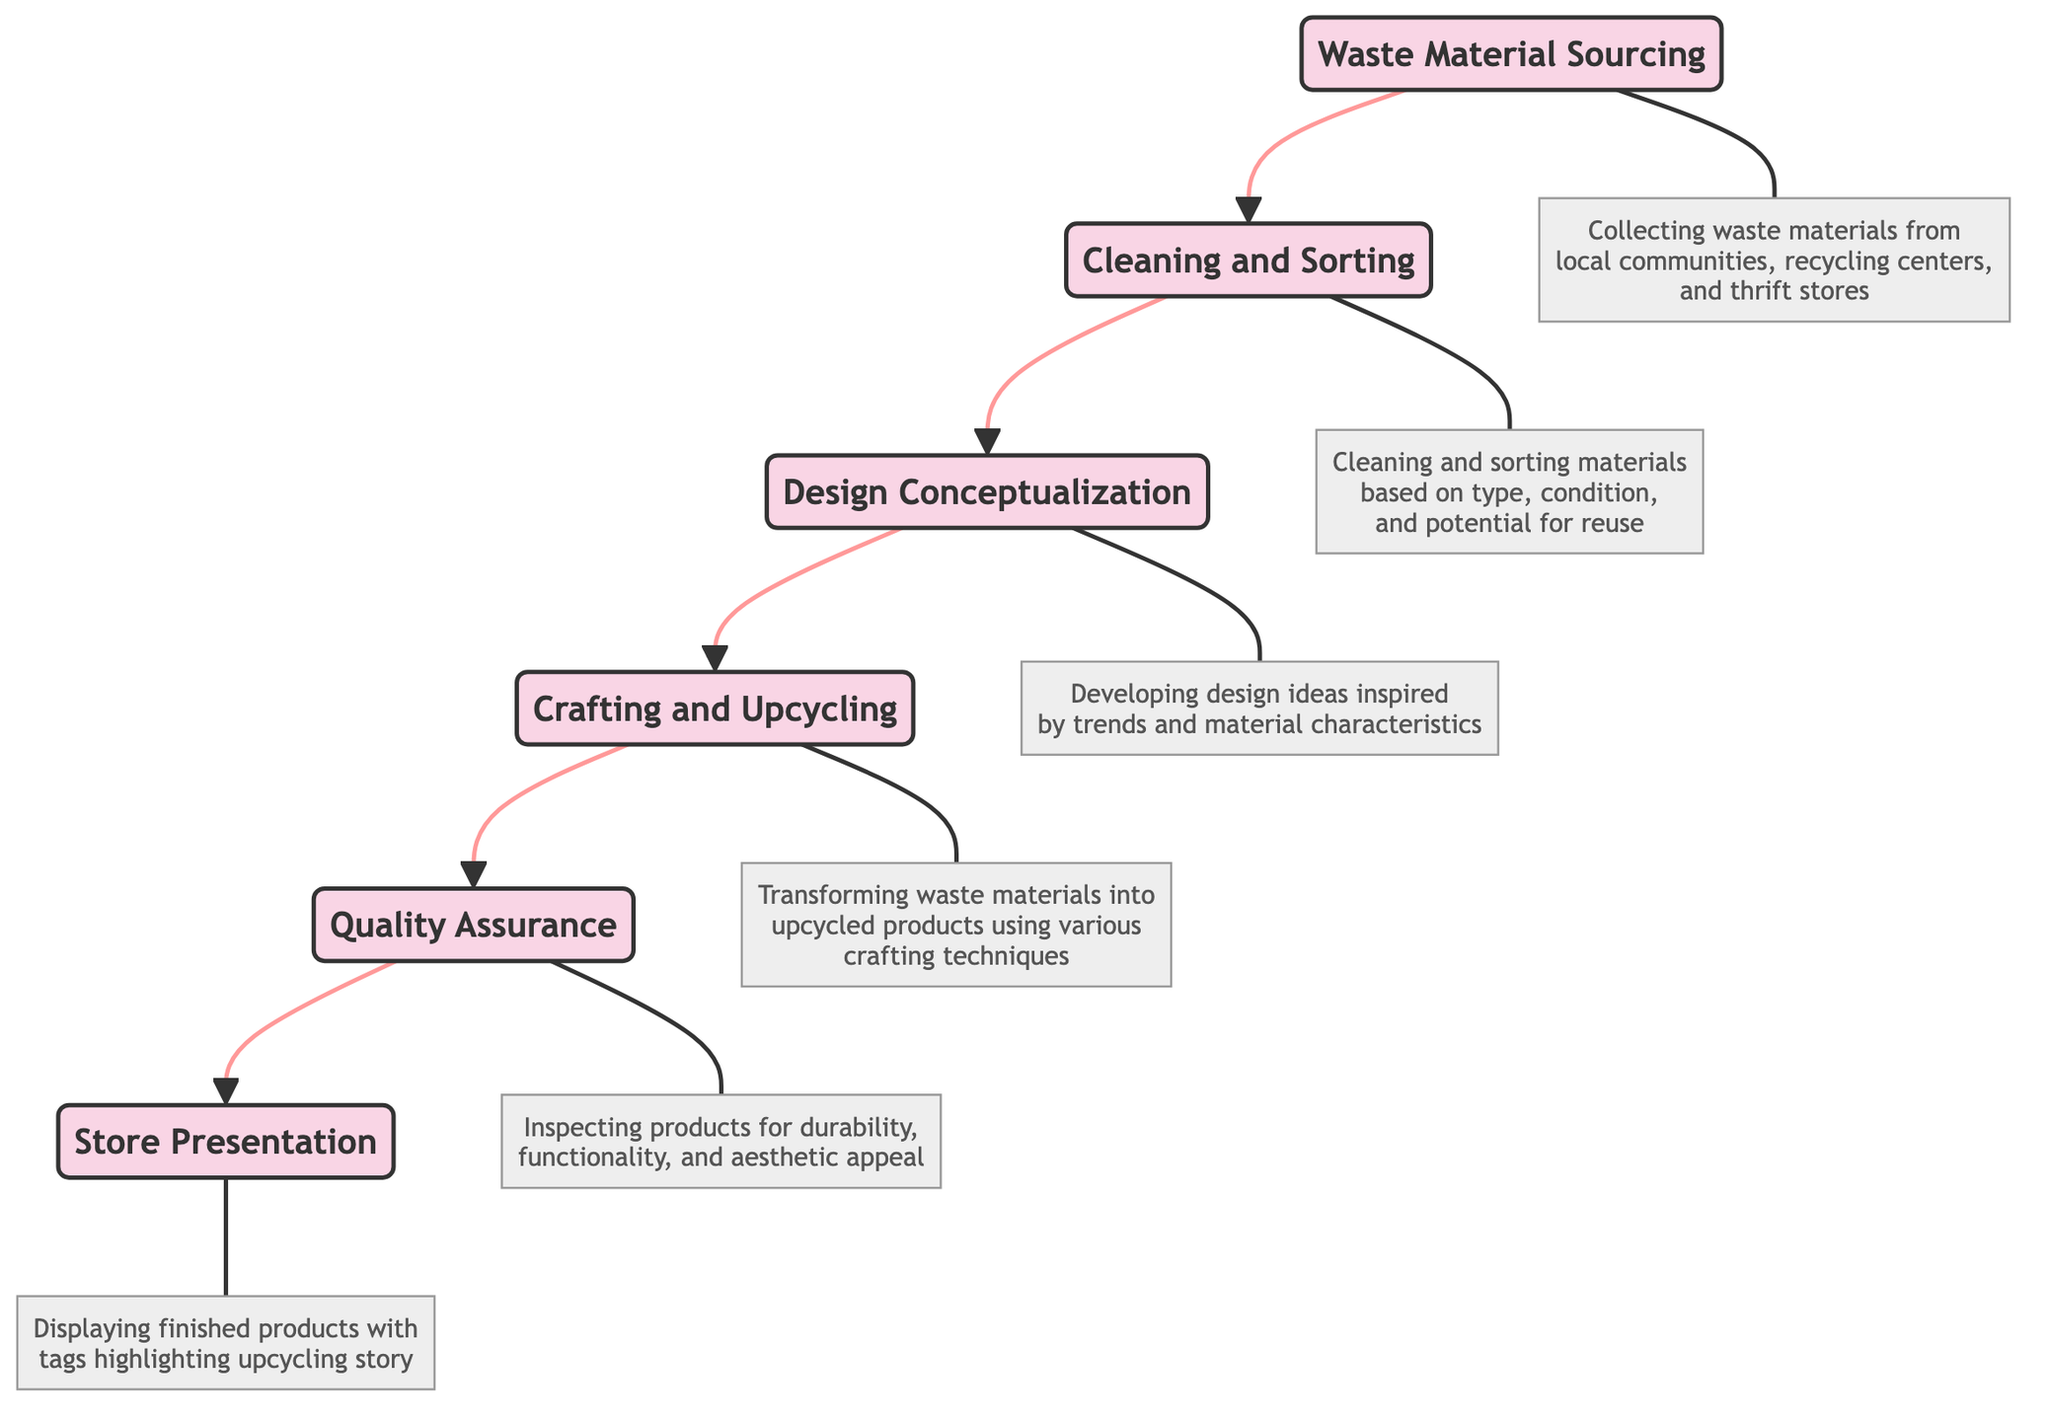What is the first stage in the supply chain? The first stage in the supply chain as depicted in the diagram is "Waste Material Sourcing," which is shown at the bottom of the flow chart.
Answer: Waste Material Sourcing How many stages are there in the supply chain? By counting the nodes in the diagram, there are a total of six stages represented in the supply chain from the bottom to the top of the flow chart.
Answer: Six What follows after "Cleaning and Sorting"? Looking at the flow of the diagram, the stage that follows "Cleaning and Sorting" is "Design Conceptualization," which is the next node above it.
Answer: Design Conceptualization Which stage is directly before "Store Presentation"? In the flow chart, "Quality Assurance" is the stage that is directly before "Store Presentation," as indicated by the arrow leading upwards from Quality Assurance to Store Presentation.
Answer: Quality Assurance What describes the "Crafting and Upcycling" stage? The description for the "Crafting and Upcycling" stage indicates it involves transforming the sorted waste materials into upcycled products using various crafting techniques.
Answer: Transforming waste materials What are the main activities in "Cleaning and Sorting"? The "Cleaning and Sorting" stage specifies the main activities involved, including thoroughly cleaning collected materials and sorting them based on type, condition, and potential for reuse.
Answer: Cleaning and sorting materials Which stage aims to ensure products meet boutique store standards? The "Quality Assurance" stage aims to ensure that the upcycled products meet the durability, functionality, and aesthetic standards of the boutique store.
Answer: Quality Assurance What type of materials do we collect in "Waste Material Sourcing"? The "Waste Material Sourcing" stage describes that we collect waste materials such as old furniture, discarded fabrics, and electronic scrap.
Answer: Old furniture, discarded fabrics, electronic scrap What is the last stage of the flow chart? The last stage of the flow chart, which is positioned at the top, is "Store Presentation," indicating it is the final part of the supply chain process.
Answer: Store Presentation 